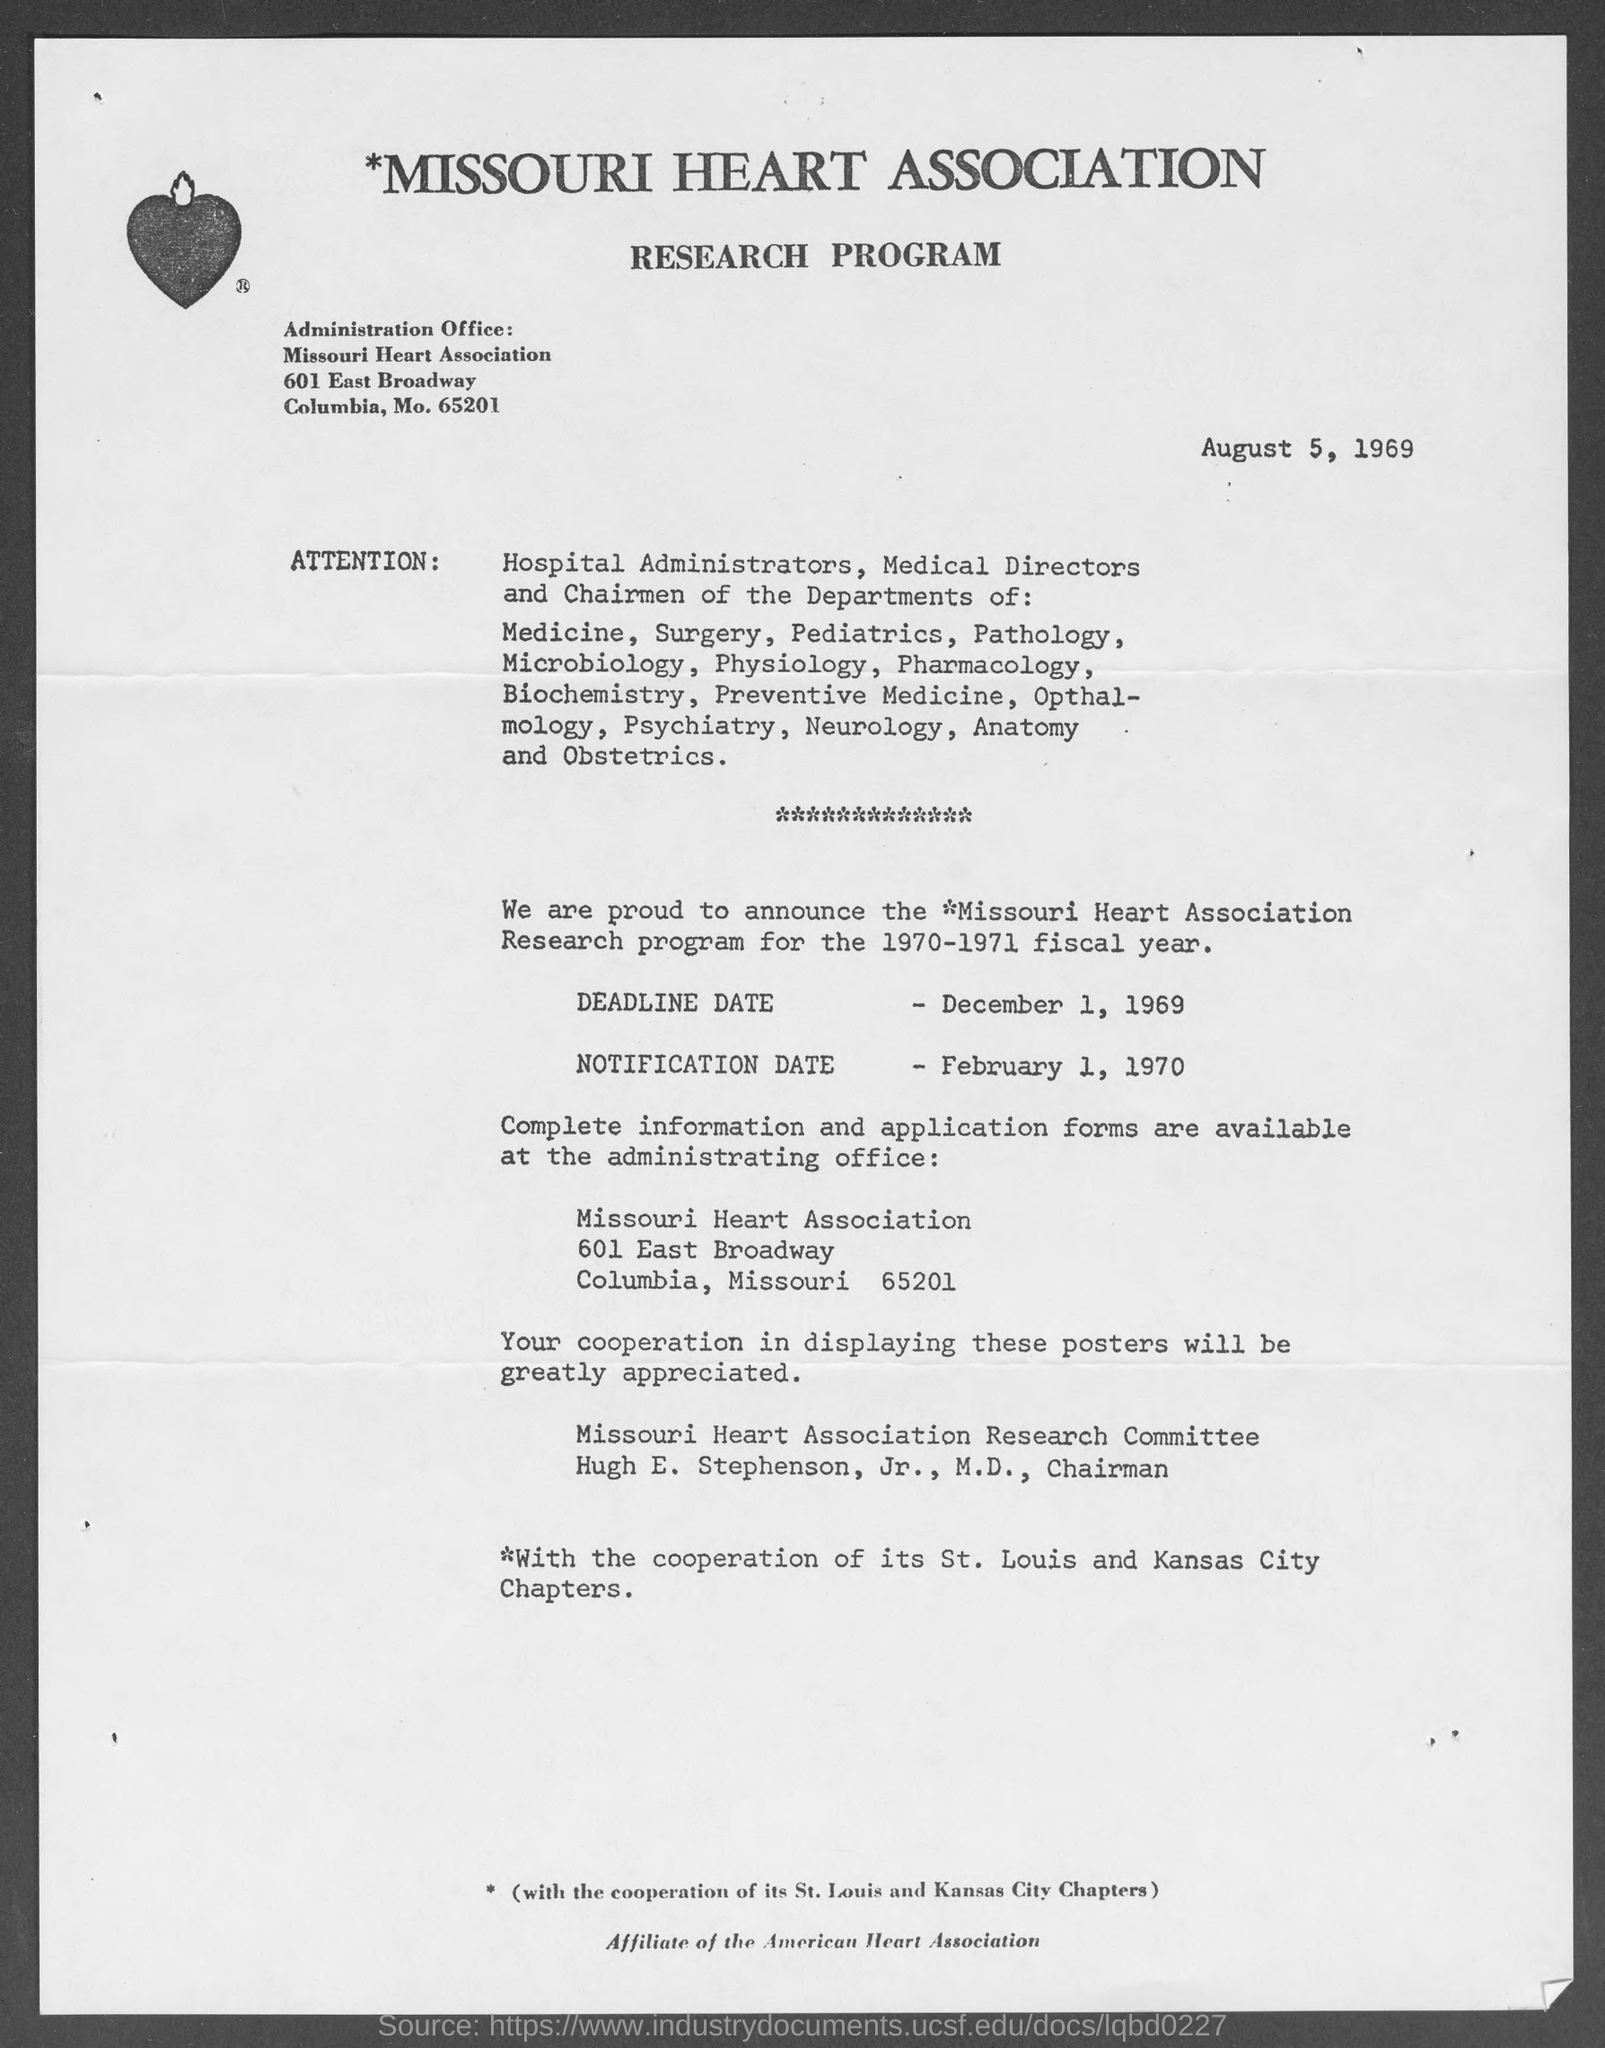Identify some key points in this picture. The name of the heart association in Missouri is... Hugh E. Stepson, Jr., M.D., is the chairman of M.D. The deadline date for the research program for the year 1970-1971 was December 1, 1969. The notification date for the research program in 1970-71 is February 1, 1970. 